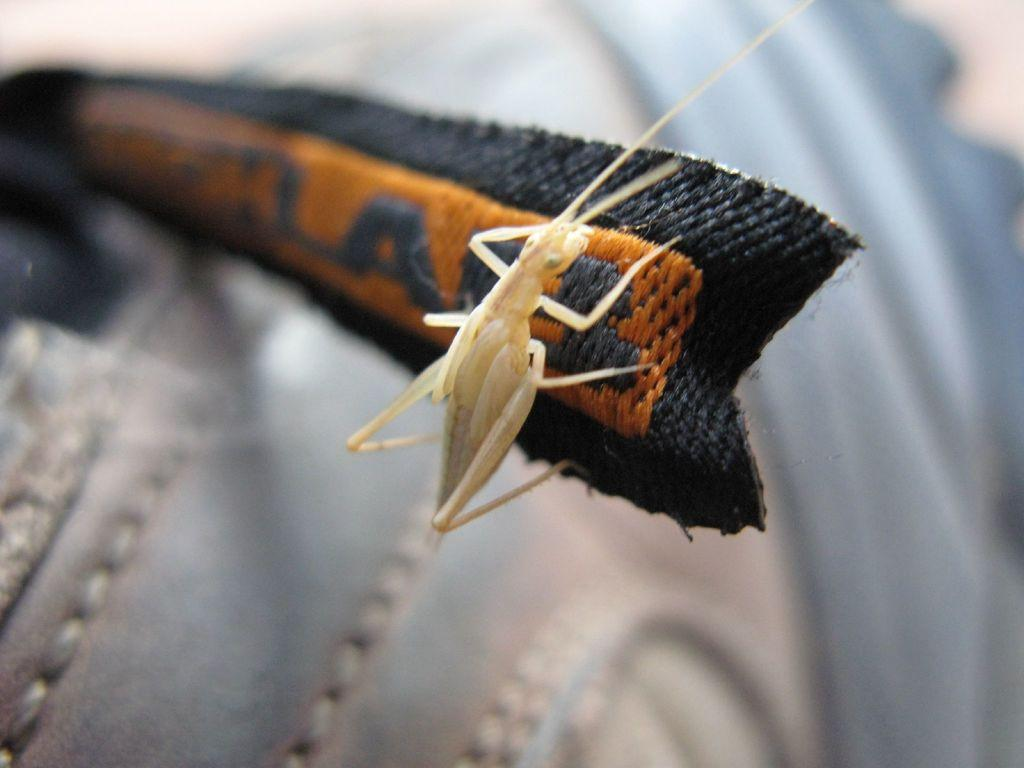What is the main subject in the center of the image? There is an object in the center of the image. What colors can be seen on the object? The object has black and orange colors. Is there any living creature on the object? Yes, there is an insect on the object. How would you describe the background of the image? The background of the image is blurred. What type of wound can be seen on the potato in the image? There is no potato present in the image, and therefore no wound can be observed. Is there a toy visible in the image? There is no toy visible in the image. 